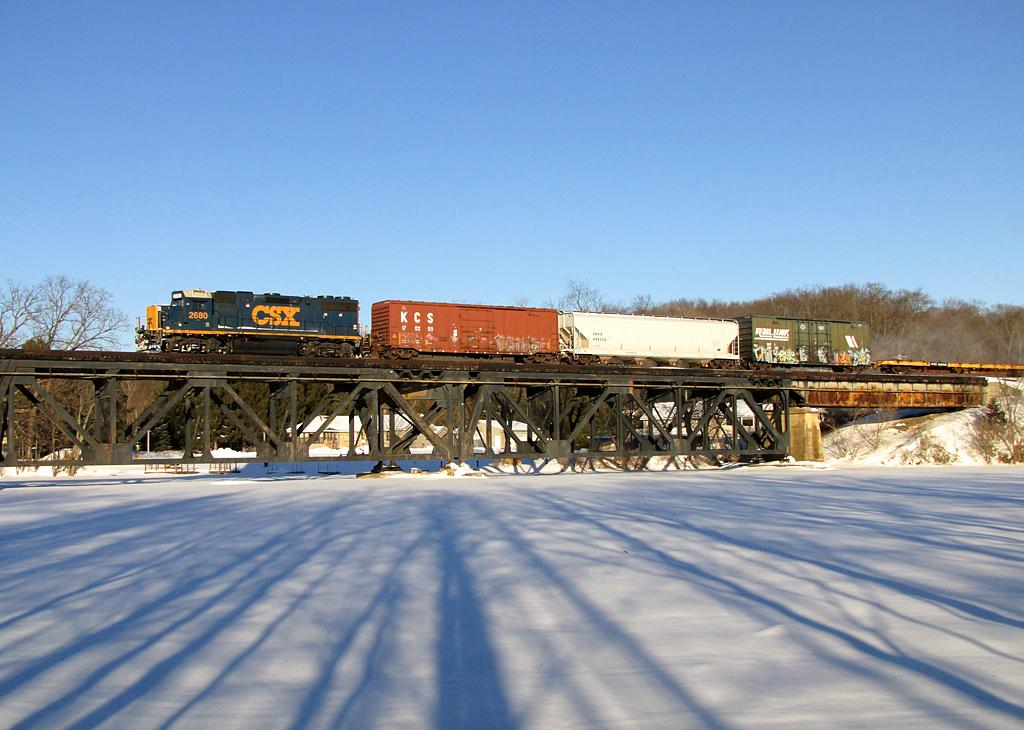Provide a one-sentence caption for the provided image. A CSX train leads a row of cars. 